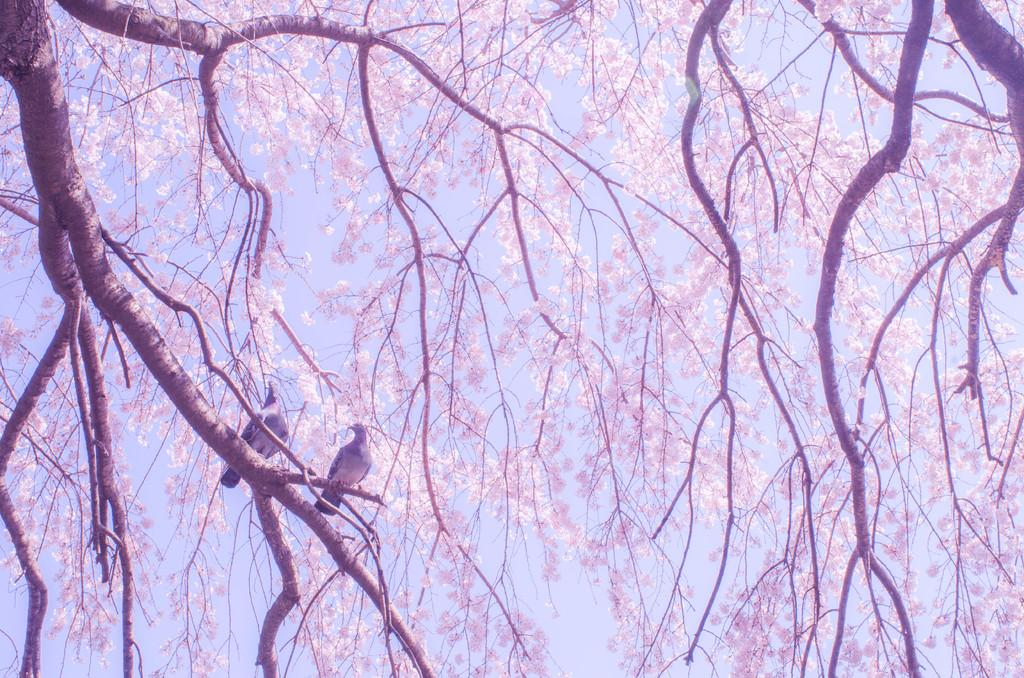What type of vegetation can be seen in the image? There are trees in the image. Can you describe the birds in the image? There are two birds on a branch in the image. What can be seen in the background of the image? The sky is visible in the background of the image. What type of scent can be detected from the orange in the image? There is no orange present in the image, so it is not possible to detect any scent. 